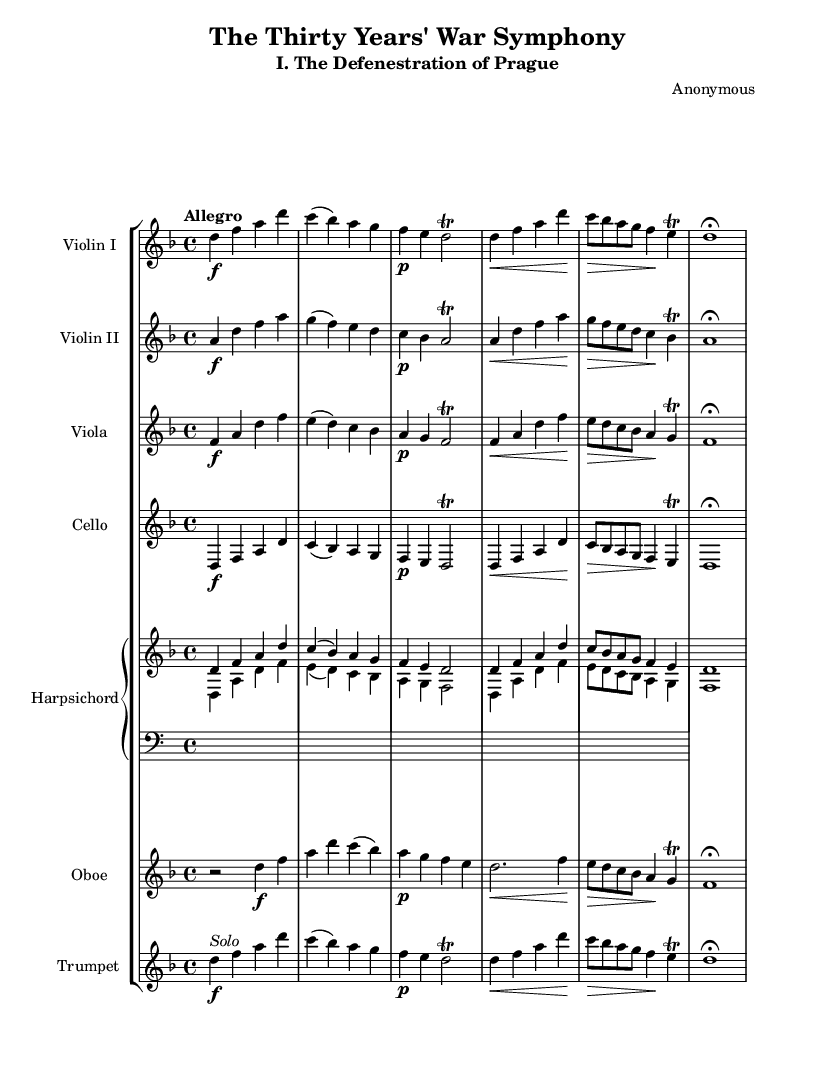What is the key signature of this music? The key signature is indicated by the presence of one flat (B♭), which situates the piece in D minor.
Answer: D minor What is the time signature of this music? The time signature is specified as 4/4, meaning there are four beats in each measure.
Answer: 4/4 What is the tempo marking for this piece? The tempo marking "Allegro" indicates a fast, lively pace for the music.
Answer: Allegro How many violin parts are present in this orchestration? There are two violin parts: Violin I and Violin II, indicated by separate staves.
Answer: Two What specific event inspired this orchestral piece? The piece is inspired by "The Defenestration of Prague," a significant event during the Thirty Years' War.
Answer: The Defenestration of Prague Which instrument has a solo indication? The trumpet part is marked with "Solo," indicating it is meant to be played as a solo.
Answer: Trumpet What is the dynamic marking for the cello in measure 1? The cello starts with the dynamic marking "f," indicating it should be played loudly.
Answer: f 